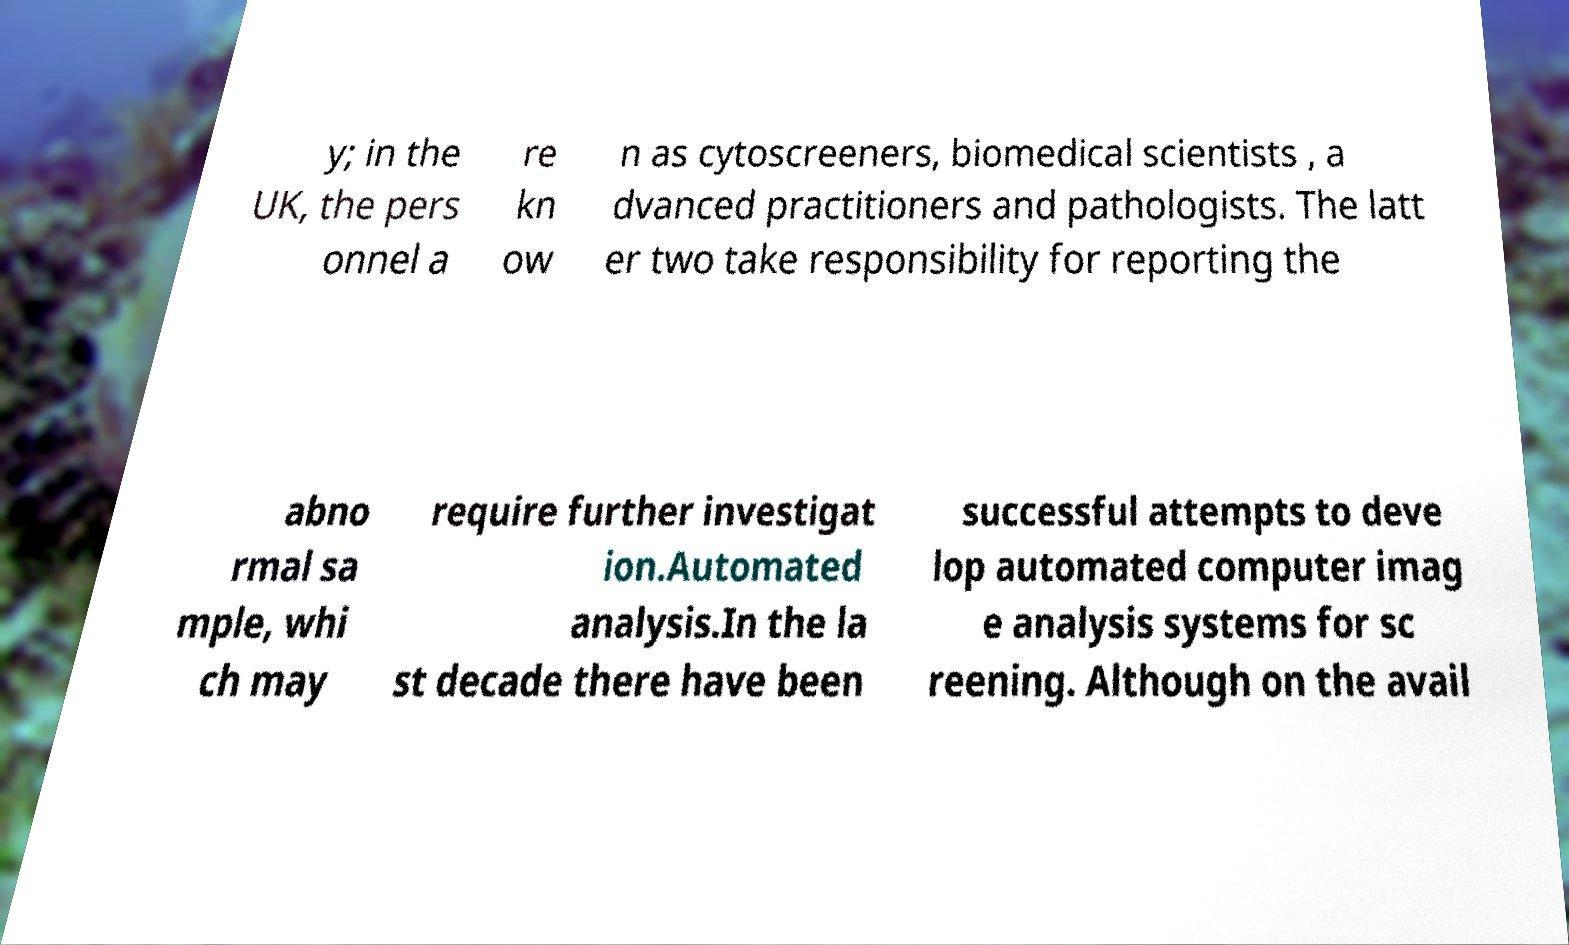Could you assist in decoding the text presented in this image and type it out clearly? y; in the UK, the pers onnel a re kn ow n as cytoscreeners, biomedical scientists , a dvanced practitioners and pathologists. The latt er two take responsibility for reporting the abno rmal sa mple, whi ch may require further investigat ion.Automated analysis.In the la st decade there have been successful attempts to deve lop automated computer imag e analysis systems for sc reening. Although on the avail 